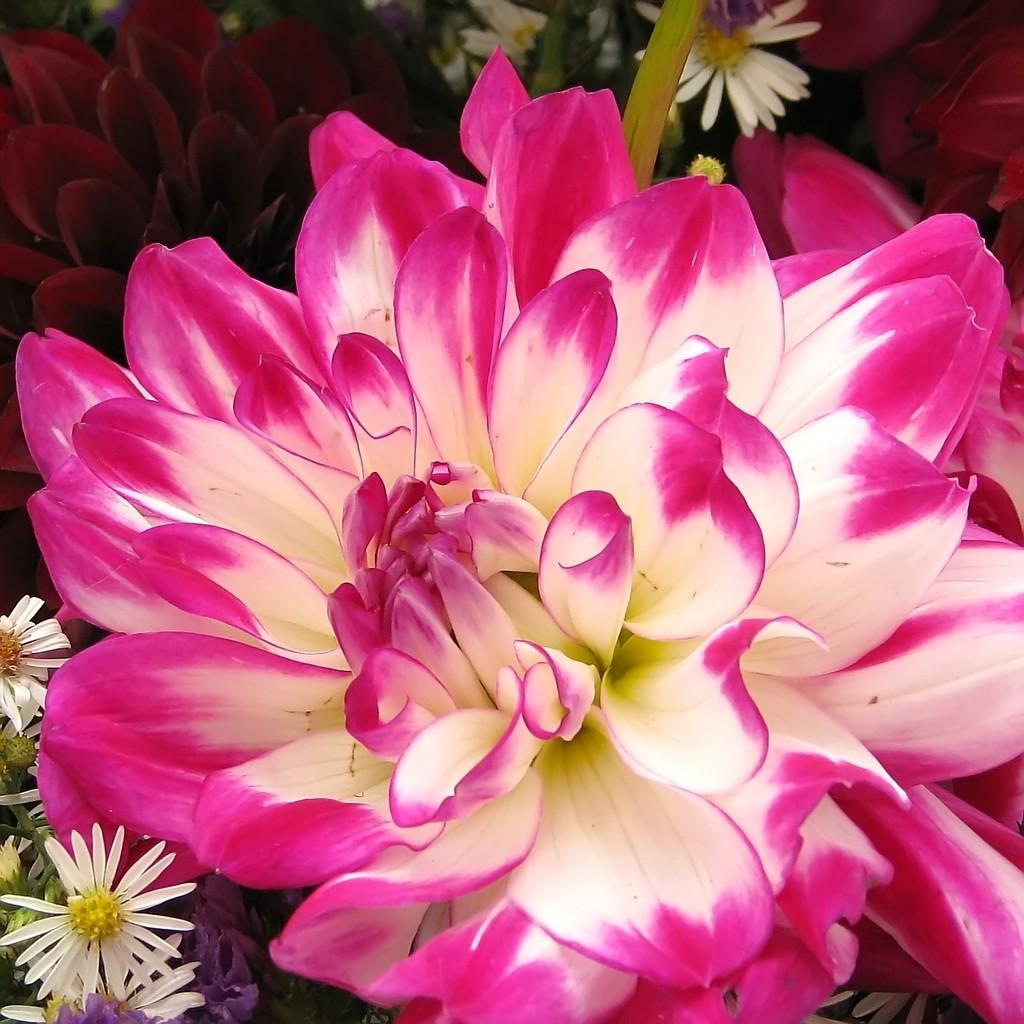What type of living organisms can be seen in the image? Flowers can be seen in the image. What type of pest can be seen attacking the flowers in the image? There is no pest present in the image, as it only features flowers. Can you hear anyone coughing in the image? There is no sound present in the image, so it is not possible to determine if anyone is coughing. 